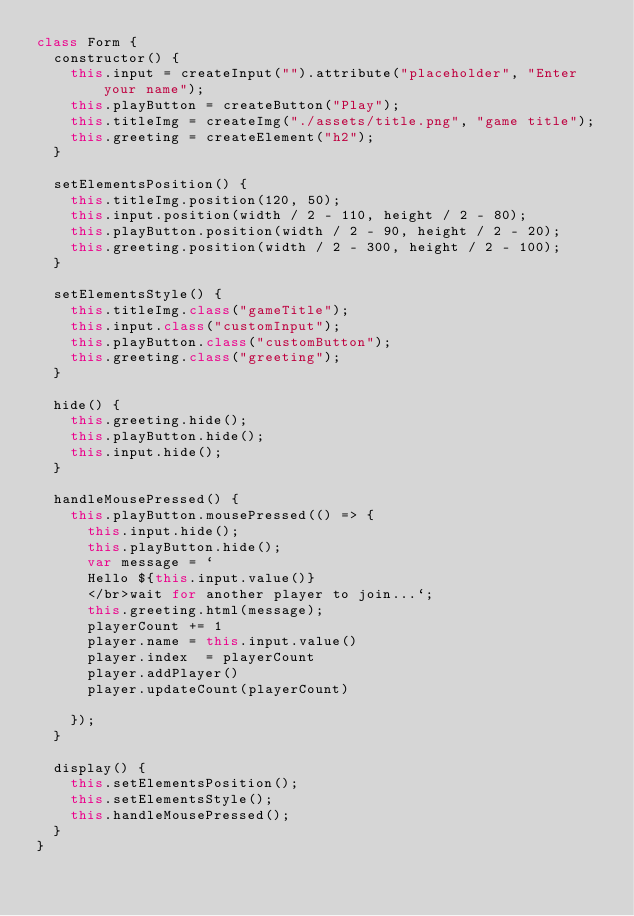Convert code to text. <code><loc_0><loc_0><loc_500><loc_500><_JavaScript_>class Form {
  constructor() {
    this.input = createInput("").attribute("placeholder", "Enter your name");
    this.playButton = createButton("Play");
    this.titleImg = createImg("./assets/title.png", "game title");
    this.greeting = createElement("h2");
  }

  setElementsPosition() {
    this.titleImg.position(120, 50);
    this.input.position(width / 2 - 110, height / 2 - 80);
    this.playButton.position(width / 2 - 90, height / 2 - 20);
    this.greeting.position(width / 2 - 300, height / 2 - 100);
  }

  setElementsStyle() {
    this.titleImg.class("gameTitle");
    this.input.class("customInput");
    this.playButton.class("customButton");
    this.greeting.class("greeting");
  }

  hide() {
    this.greeting.hide();
    this.playButton.hide();
    this.input.hide();
  }

  handleMousePressed() {
    this.playButton.mousePressed(() => {
      this.input.hide();
      this.playButton.hide();
      var message = `
      Hello ${this.input.value()}
      </br>wait for another player to join...`;
      this.greeting.html(message);
      playerCount += 1 
      player.name = this.input.value()
      player.index  = playerCount
      player.addPlayer()
      player.updateCount(playerCount)

    });
  }

  display() {
    this.setElementsPosition();
    this.setElementsStyle();
    this.handleMousePressed();
  }
}
</code> 